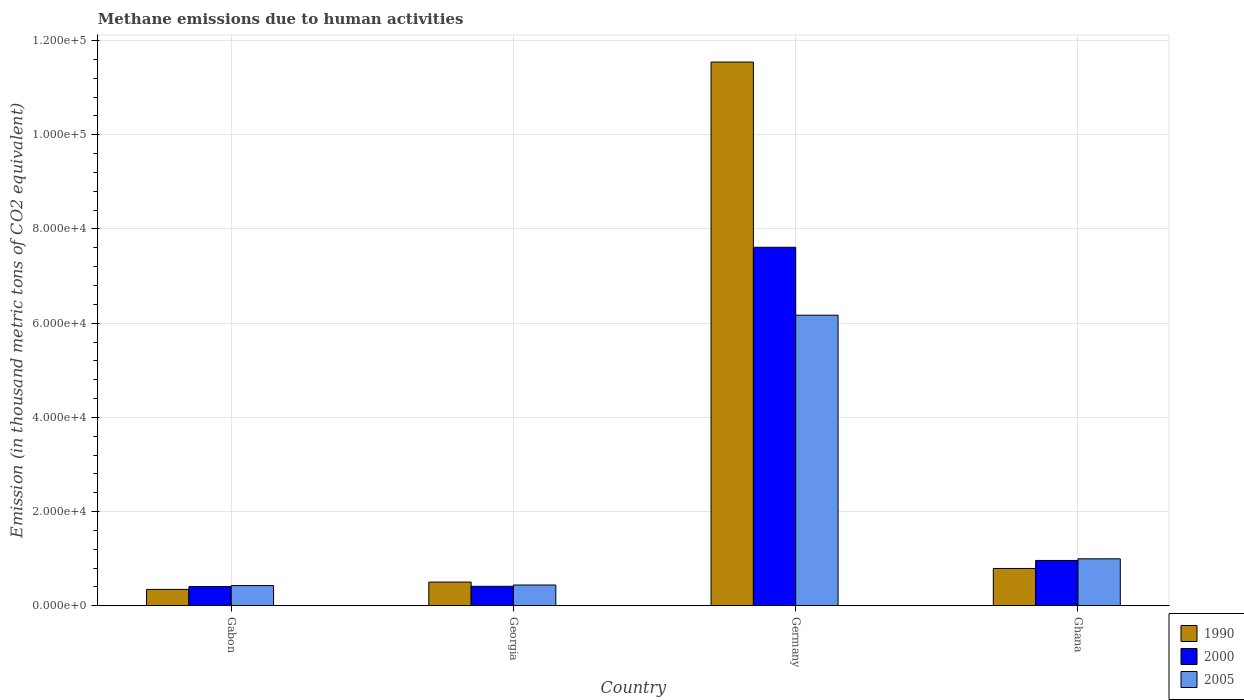How many groups of bars are there?
Ensure brevity in your answer.  4. Are the number of bars on each tick of the X-axis equal?
Your response must be concise. Yes. How many bars are there on the 1st tick from the left?
Your response must be concise. 3. How many bars are there on the 1st tick from the right?
Your answer should be very brief. 3. What is the label of the 2nd group of bars from the left?
Provide a succinct answer. Georgia. What is the amount of methane emitted in 2005 in Ghana?
Your response must be concise. 9975.3. Across all countries, what is the maximum amount of methane emitted in 2000?
Provide a short and direct response. 7.61e+04. Across all countries, what is the minimum amount of methane emitted in 2000?
Your answer should be very brief. 4082.1. In which country was the amount of methane emitted in 1990 minimum?
Your response must be concise. Gabon. What is the total amount of methane emitted in 1990 in the graph?
Provide a short and direct response. 1.32e+05. What is the difference between the amount of methane emitted in 2005 in Gabon and that in Ghana?
Give a very brief answer. -5677.2. What is the difference between the amount of methane emitted in 2000 in Ghana and the amount of methane emitted in 1990 in Germany?
Offer a very short reply. -1.06e+05. What is the average amount of methane emitted in 2000 per country?
Offer a terse response. 2.35e+04. What is the difference between the amount of methane emitted of/in 2005 and amount of methane emitted of/in 1990 in Georgia?
Your answer should be very brief. -623.8. In how many countries, is the amount of methane emitted in 1990 greater than 16000 thousand metric tons?
Give a very brief answer. 1. What is the ratio of the amount of methane emitted in 2000 in Germany to that in Ghana?
Your response must be concise. 7.91. Is the difference between the amount of methane emitted in 2005 in Georgia and Ghana greater than the difference between the amount of methane emitted in 1990 in Georgia and Ghana?
Provide a succinct answer. No. What is the difference between the highest and the second highest amount of methane emitted in 2005?
Give a very brief answer. 5.73e+04. What is the difference between the highest and the lowest amount of methane emitted in 1990?
Your answer should be compact. 1.12e+05. In how many countries, is the amount of methane emitted in 1990 greater than the average amount of methane emitted in 1990 taken over all countries?
Your answer should be very brief. 1. Is the sum of the amount of methane emitted in 2000 in Germany and Ghana greater than the maximum amount of methane emitted in 1990 across all countries?
Make the answer very short. No. What does the 2nd bar from the right in Gabon represents?
Your answer should be very brief. 2000. What is the difference between two consecutive major ticks on the Y-axis?
Provide a short and direct response. 2.00e+04. Does the graph contain any zero values?
Provide a succinct answer. No. How many legend labels are there?
Your answer should be very brief. 3. How are the legend labels stacked?
Make the answer very short. Vertical. What is the title of the graph?
Make the answer very short. Methane emissions due to human activities. What is the label or title of the Y-axis?
Provide a succinct answer. Emission (in thousand metric tons of CO2 equivalent). What is the Emission (in thousand metric tons of CO2 equivalent) of 1990 in Gabon?
Your answer should be very brief. 3478.5. What is the Emission (in thousand metric tons of CO2 equivalent) of 2000 in Gabon?
Offer a very short reply. 4082.1. What is the Emission (in thousand metric tons of CO2 equivalent) in 2005 in Gabon?
Give a very brief answer. 4298.1. What is the Emission (in thousand metric tons of CO2 equivalent) in 1990 in Georgia?
Your answer should be compact. 5037. What is the Emission (in thousand metric tons of CO2 equivalent) in 2000 in Georgia?
Provide a short and direct response. 4137.4. What is the Emission (in thousand metric tons of CO2 equivalent) of 2005 in Georgia?
Make the answer very short. 4413.2. What is the Emission (in thousand metric tons of CO2 equivalent) of 1990 in Germany?
Your answer should be very brief. 1.15e+05. What is the Emission (in thousand metric tons of CO2 equivalent) in 2000 in Germany?
Offer a terse response. 7.61e+04. What is the Emission (in thousand metric tons of CO2 equivalent) of 2005 in Germany?
Ensure brevity in your answer.  6.17e+04. What is the Emission (in thousand metric tons of CO2 equivalent) in 1990 in Ghana?
Make the answer very short. 7924.7. What is the Emission (in thousand metric tons of CO2 equivalent) in 2000 in Ghana?
Give a very brief answer. 9627.9. What is the Emission (in thousand metric tons of CO2 equivalent) in 2005 in Ghana?
Your response must be concise. 9975.3. Across all countries, what is the maximum Emission (in thousand metric tons of CO2 equivalent) of 1990?
Your answer should be very brief. 1.15e+05. Across all countries, what is the maximum Emission (in thousand metric tons of CO2 equivalent) of 2000?
Ensure brevity in your answer.  7.61e+04. Across all countries, what is the maximum Emission (in thousand metric tons of CO2 equivalent) of 2005?
Offer a very short reply. 6.17e+04. Across all countries, what is the minimum Emission (in thousand metric tons of CO2 equivalent) of 1990?
Offer a very short reply. 3478.5. Across all countries, what is the minimum Emission (in thousand metric tons of CO2 equivalent) of 2000?
Your answer should be compact. 4082.1. Across all countries, what is the minimum Emission (in thousand metric tons of CO2 equivalent) in 2005?
Give a very brief answer. 4298.1. What is the total Emission (in thousand metric tons of CO2 equivalent) of 1990 in the graph?
Provide a succinct answer. 1.32e+05. What is the total Emission (in thousand metric tons of CO2 equivalent) of 2000 in the graph?
Your response must be concise. 9.40e+04. What is the total Emission (in thousand metric tons of CO2 equivalent) in 2005 in the graph?
Keep it short and to the point. 8.04e+04. What is the difference between the Emission (in thousand metric tons of CO2 equivalent) in 1990 in Gabon and that in Georgia?
Give a very brief answer. -1558.5. What is the difference between the Emission (in thousand metric tons of CO2 equivalent) of 2000 in Gabon and that in Georgia?
Offer a very short reply. -55.3. What is the difference between the Emission (in thousand metric tons of CO2 equivalent) in 2005 in Gabon and that in Georgia?
Keep it short and to the point. -115.1. What is the difference between the Emission (in thousand metric tons of CO2 equivalent) of 1990 in Gabon and that in Germany?
Keep it short and to the point. -1.12e+05. What is the difference between the Emission (in thousand metric tons of CO2 equivalent) in 2000 in Gabon and that in Germany?
Your answer should be very brief. -7.20e+04. What is the difference between the Emission (in thousand metric tons of CO2 equivalent) of 2005 in Gabon and that in Germany?
Offer a very short reply. -5.74e+04. What is the difference between the Emission (in thousand metric tons of CO2 equivalent) of 1990 in Gabon and that in Ghana?
Make the answer very short. -4446.2. What is the difference between the Emission (in thousand metric tons of CO2 equivalent) of 2000 in Gabon and that in Ghana?
Provide a short and direct response. -5545.8. What is the difference between the Emission (in thousand metric tons of CO2 equivalent) in 2005 in Gabon and that in Ghana?
Offer a terse response. -5677.2. What is the difference between the Emission (in thousand metric tons of CO2 equivalent) in 1990 in Georgia and that in Germany?
Provide a succinct answer. -1.10e+05. What is the difference between the Emission (in thousand metric tons of CO2 equivalent) of 2000 in Georgia and that in Germany?
Provide a short and direct response. -7.20e+04. What is the difference between the Emission (in thousand metric tons of CO2 equivalent) in 2005 in Georgia and that in Germany?
Your answer should be compact. -5.73e+04. What is the difference between the Emission (in thousand metric tons of CO2 equivalent) in 1990 in Georgia and that in Ghana?
Give a very brief answer. -2887.7. What is the difference between the Emission (in thousand metric tons of CO2 equivalent) of 2000 in Georgia and that in Ghana?
Provide a short and direct response. -5490.5. What is the difference between the Emission (in thousand metric tons of CO2 equivalent) in 2005 in Georgia and that in Ghana?
Offer a very short reply. -5562.1. What is the difference between the Emission (in thousand metric tons of CO2 equivalent) of 1990 in Germany and that in Ghana?
Provide a short and direct response. 1.08e+05. What is the difference between the Emission (in thousand metric tons of CO2 equivalent) of 2000 in Germany and that in Ghana?
Make the answer very short. 6.65e+04. What is the difference between the Emission (in thousand metric tons of CO2 equivalent) of 2005 in Germany and that in Ghana?
Provide a short and direct response. 5.17e+04. What is the difference between the Emission (in thousand metric tons of CO2 equivalent) in 1990 in Gabon and the Emission (in thousand metric tons of CO2 equivalent) in 2000 in Georgia?
Your answer should be very brief. -658.9. What is the difference between the Emission (in thousand metric tons of CO2 equivalent) in 1990 in Gabon and the Emission (in thousand metric tons of CO2 equivalent) in 2005 in Georgia?
Offer a terse response. -934.7. What is the difference between the Emission (in thousand metric tons of CO2 equivalent) of 2000 in Gabon and the Emission (in thousand metric tons of CO2 equivalent) of 2005 in Georgia?
Provide a short and direct response. -331.1. What is the difference between the Emission (in thousand metric tons of CO2 equivalent) in 1990 in Gabon and the Emission (in thousand metric tons of CO2 equivalent) in 2000 in Germany?
Your response must be concise. -7.26e+04. What is the difference between the Emission (in thousand metric tons of CO2 equivalent) in 1990 in Gabon and the Emission (in thousand metric tons of CO2 equivalent) in 2005 in Germany?
Offer a terse response. -5.82e+04. What is the difference between the Emission (in thousand metric tons of CO2 equivalent) of 2000 in Gabon and the Emission (in thousand metric tons of CO2 equivalent) of 2005 in Germany?
Ensure brevity in your answer.  -5.76e+04. What is the difference between the Emission (in thousand metric tons of CO2 equivalent) of 1990 in Gabon and the Emission (in thousand metric tons of CO2 equivalent) of 2000 in Ghana?
Provide a short and direct response. -6149.4. What is the difference between the Emission (in thousand metric tons of CO2 equivalent) in 1990 in Gabon and the Emission (in thousand metric tons of CO2 equivalent) in 2005 in Ghana?
Make the answer very short. -6496.8. What is the difference between the Emission (in thousand metric tons of CO2 equivalent) in 2000 in Gabon and the Emission (in thousand metric tons of CO2 equivalent) in 2005 in Ghana?
Keep it short and to the point. -5893.2. What is the difference between the Emission (in thousand metric tons of CO2 equivalent) in 1990 in Georgia and the Emission (in thousand metric tons of CO2 equivalent) in 2000 in Germany?
Your response must be concise. -7.11e+04. What is the difference between the Emission (in thousand metric tons of CO2 equivalent) of 1990 in Georgia and the Emission (in thousand metric tons of CO2 equivalent) of 2005 in Germany?
Offer a terse response. -5.67e+04. What is the difference between the Emission (in thousand metric tons of CO2 equivalent) of 2000 in Georgia and the Emission (in thousand metric tons of CO2 equivalent) of 2005 in Germany?
Your answer should be compact. -5.76e+04. What is the difference between the Emission (in thousand metric tons of CO2 equivalent) in 1990 in Georgia and the Emission (in thousand metric tons of CO2 equivalent) in 2000 in Ghana?
Offer a very short reply. -4590.9. What is the difference between the Emission (in thousand metric tons of CO2 equivalent) in 1990 in Georgia and the Emission (in thousand metric tons of CO2 equivalent) in 2005 in Ghana?
Keep it short and to the point. -4938.3. What is the difference between the Emission (in thousand metric tons of CO2 equivalent) in 2000 in Georgia and the Emission (in thousand metric tons of CO2 equivalent) in 2005 in Ghana?
Your answer should be compact. -5837.9. What is the difference between the Emission (in thousand metric tons of CO2 equivalent) of 1990 in Germany and the Emission (in thousand metric tons of CO2 equivalent) of 2000 in Ghana?
Your answer should be very brief. 1.06e+05. What is the difference between the Emission (in thousand metric tons of CO2 equivalent) of 1990 in Germany and the Emission (in thousand metric tons of CO2 equivalent) of 2005 in Ghana?
Your response must be concise. 1.05e+05. What is the difference between the Emission (in thousand metric tons of CO2 equivalent) of 2000 in Germany and the Emission (in thousand metric tons of CO2 equivalent) of 2005 in Ghana?
Offer a very short reply. 6.61e+04. What is the average Emission (in thousand metric tons of CO2 equivalent) of 1990 per country?
Your answer should be very brief. 3.30e+04. What is the average Emission (in thousand metric tons of CO2 equivalent) in 2000 per country?
Provide a succinct answer. 2.35e+04. What is the average Emission (in thousand metric tons of CO2 equivalent) of 2005 per country?
Make the answer very short. 2.01e+04. What is the difference between the Emission (in thousand metric tons of CO2 equivalent) of 1990 and Emission (in thousand metric tons of CO2 equivalent) of 2000 in Gabon?
Your answer should be compact. -603.6. What is the difference between the Emission (in thousand metric tons of CO2 equivalent) of 1990 and Emission (in thousand metric tons of CO2 equivalent) of 2005 in Gabon?
Your response must be concise. -819.6. What is the difference between the Emission (in thousand metric tons of CO2 equivalent) of 2000 and Emission (in thousand metric tons of CO2 equivalent) of 2005 in Gabon?
Keep it short and to the point. -216. What is the difference between the Emission (in thousand metric tons of CO2 equivalent) in 1990 and Emission (in thousand metric tons of CO2 equivalent) in 2000 in Georgia?
Offer a terse response. 899.6. What is the difference between the Emission (in thousand metric tons of CO2 equivalent) in 1990 and Emission (in thousand metric tons of CO2 equivalent) in 2005 in Georgia?
Make the answer very short. 623.8. What is the difference between the Emission (in thousand metric tons of CO2 equivalent) in 2000 and Emission (in thousand metric tons of CO2 equivalent) in 2005 in Georgia?
Provide a succinct answer. -275.8. What is the difference between the Emission (in thousand metric tons of CO2 equivalent) of 1990 and Emission (in thousand metric tons of CO2 equivalent) of 2000 in Germany?
Your answer should be compact. 3.93e+04. What is the difference between the Emission (in thousand metric tons of CO2 equivalent) of 1990 and Emission (in thousand metric tons of CO2 equivalent) of 2005 in Germany?
Offer a terse response. 5.37e+04. What is the difference between the Emission (in thousand metric tons of CO2 equivalent) in 2000 and Emission (in thousand metric tons of CO2 equivalent) in 2005 in Germany?
Ensure brevity in your answer.  1.44e+04. What is the difference between the Emission (in thousand metric tons of CO2 equivalent) of 1990 and Emission (in thousand metric tons of CO2 equivalent) of 2000 in Ghana?
Your answer should be compact. -1703.2. What is the difference between the Emission (in thousand metric tons of CO2 equivalent) of 1990 and Emission (in thousand metric tons of CO2 equivalent) of 2005 in Ghana?
Make the answer very short. -2050.6. What is the difference between the Emission (in thousand metric tons of CO2 equivalent) of 2000 and Emission (in thousand metric tons of CO2 equivalent) of 2005 in Ghana?
Give a very brief answer. -347.4. What is the ratio of the Emission (in thousand metric tons of CO2 equivalent) in 1990 in Gabon to that in Georgia?
Your response must be concise. 0.69. What is the ratio of the Emission (in thousand metric tons of CO2 equivalent) of 2000 in Gabon to that in Georgia?
Give a very brief answer. 0.99. What is the ratio of the Emission (in thousand metric tons of CO2 equivalent) in 2005 in Gabon to that in Georgia?
Keep it short and to the point. 0.97. What is the ratio of the Emission (in thousand metric tons of CO2 equivalent) in 1990 in Gabon to that in Germany?
Your answer should be very brief. 0.03. What is the ratio of the Emission (in thousand metric tons of CO2 equivalent) in 2000 in Gabon to that in Germany?
Offer a very short reply. 0.05. What is the ratio of the Emission (in thousand metric tons of CO2 equivalent) in 2005 in Gabon to that in Germany?
Your answer should be very brief. 0.07. What is the ratio of the Emission (in thousand metric tons of CO2 equivalent) in 1990 in Gabon to that in Ghana?
Provide a short and direct response. 0.44. What is the ratio of the Emission (in thousand metric tons of CO2 equivalent) in 2000 in Gabon to that in Ghana?
Make the answer very short. 0.42. What is the ratio of the Emission (in thousand metric tons of CO2 equivalent) of 2005 in Gabon to that in Ghana?
Your answer should be compact. 0.43. What is the ratio of the Emission (in thousand metric tons of CO2 equivalent) of 1990 in Georgia to that in Germany?
Make the answer very short. 0.04. What is the ratio of the Emission (in thousand metric tons of CO2 equivalent) in 2000 in Georgia to that in Germany?
Give a very brief answer. 0.05. What is the ratio of the Emission (in thousand metric tons of CO2 equivalent) of 2005 in Georgia to that in Germany?
Offer a terse response. 0.07. What is the ratio of the Emission (in thousand metric tons of CO2 equivalent) of 1990 in Georgia to that in Ghana?
Make the answer very short. 0.64. What is the ratio of the Emission (in thousand metric tons of CO2 equivalent) in 2000 in Georgia to that in Ghana?
Give a very brief answer. 0.43. What is the ratio of the Emission (in thousand metric tons of CO2 equivalent) of 2005 in Georgia to that in Ghana?
Your answer should be very brief. 0.44. What is the ratio of the Emission (in thousand metric tons of CO2 equivalent) in 1990 in Germany to that in Ghana?
Offer a terse response. 14.57. What is the ratio of the Emission (in thousand metric tons of CO2 equivalent) of 2000 in Germany to that in Ghana?
Provide a short and direct response. 7.91. What is the ratio of the Emission (in thousand metric tons of CO2 equivalent) of 2005 in Germany to that in Ghana?
Offer a very short reply. 6.19. What is the difference between the highest and the second highest Emission (in thousand metric tons of CO2 equivalent) of 1990?
Your response must be concise. 1.08e+05. What is the difference between the highest and the second highest Emission (in thousand metric tons of CO2 equivalent) of 2000?
Give a very brief answer. 6.65e+04. What is the difference between the highest and the second highest Emission (in thousand metric tons of CO2 equivalent) in 2005?
Offer a terse response. 5.17e+04. What is the difference between the highest and the lowest Emission (in thousand metric tons of CO2 equivalent) in 1990?
Provide a short and direct response. 1.12e+05. What is the difference between the highest and the lowest Emission (in thousand metric tons of CO2 equivalent) of 2000?
Provide a succinct answer. 7.20e+04. What is the difference between the highest and the lowest Emission (in thousand metric tons of CO2 equivalent) in 2005?
Offer a very short reply. 5.74e+04. 